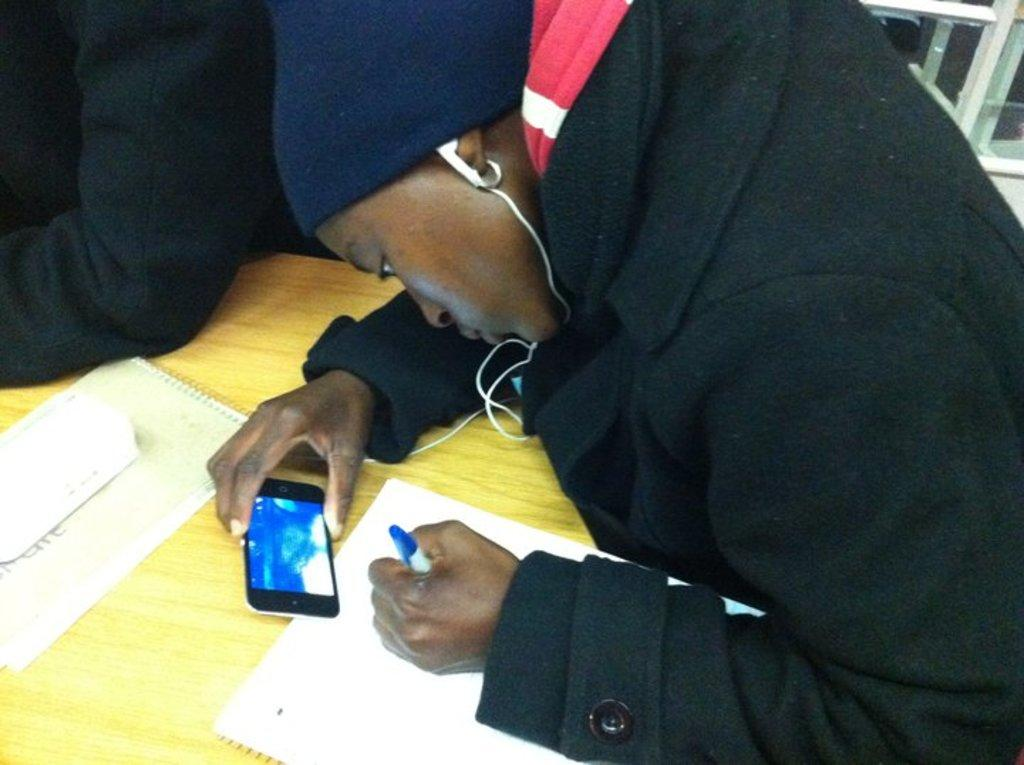What is the person in the image doing? The person is sitting on a chair and holding a mobile phone in one hand and a pen in the other hand. What object is the person holding in their hand that is not a pen? The person is holding a mobile phone in their hand. What can be seen in the background of the image? There is a table in the background of the image, and papers are placed on the table. What type of yam is the person eating in the image? There is no yam present in the image; the person is holding a mobile phone and a pen. How does the person's pain affect their ability to write with the pen in the image? There is no indication of pain in the image, and the person is holding a pen and appears to be able to use it. 